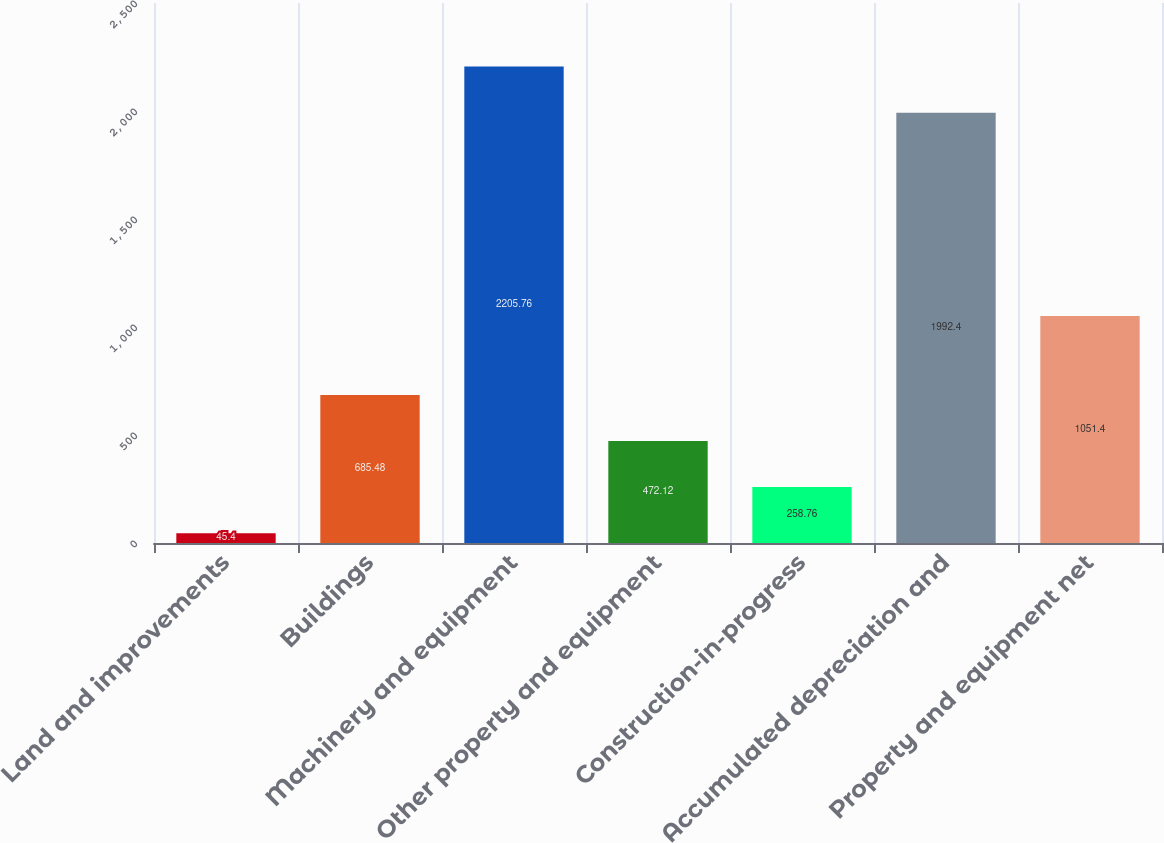<chart> <loc_0><loc_0><loc_500><loc_500><bar_chart><fcel>Land and improvements<fcel>Buildings<fcel>Machinery and equipment<fcel>Other property and equipment<fcel>Construction-in-progress<fcel>Accumulated depreciation and<fcel>Property and equipment net<nl><fcel>45.4<fcel>685.48<fcel>2205.76<fcel>472.12<fcel>258.76<fcel>1992.4<fcel>1051.4<nl></chart> 